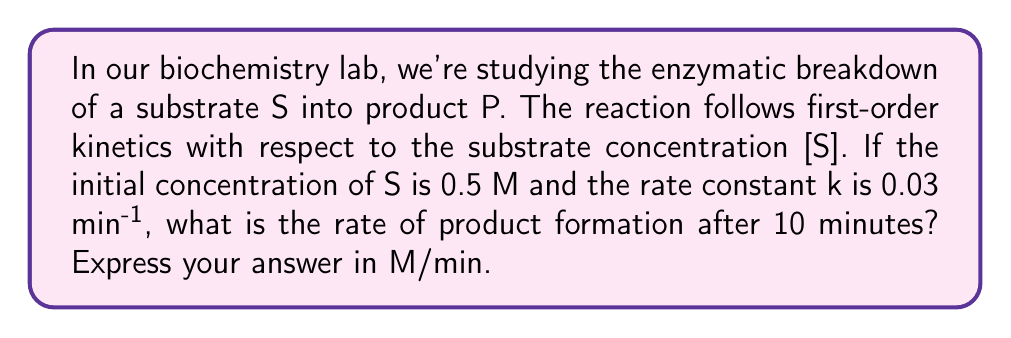Show me your answer to this math problem. Let's approach this step-by-step:

1) For a first-order reaction, the rate law is:
   $$\text{Rate} = k[S]$$

2) We need to find [S] at t = 10 minutes. The integrated rate law for a first-order reaction is:
   $$[S] = [S]_0 e^{-kt}$$

3) Let's substitute our known values:
   [S]_0 = 0.5 M
   k = 0.03 min^(-1)
   t = 10 min

   $$[S] = 0.5 e^{-0.03 \times 10}$$

4) Calculate:
   $$[S] = 0.5 e^{-0.3} = 0.5 \times 0.7408 = 0.3704 \text{ M}$$

5) Now we can use this concentration in our rate law:
   $$\text{Rate} = k[S] = 0.03 \times 0.3704$$

6) Calculate the final rate:
   $$\text{Rate} = 0.011112 \text{ M/min}$$
Answer: 0.011112 M/min 